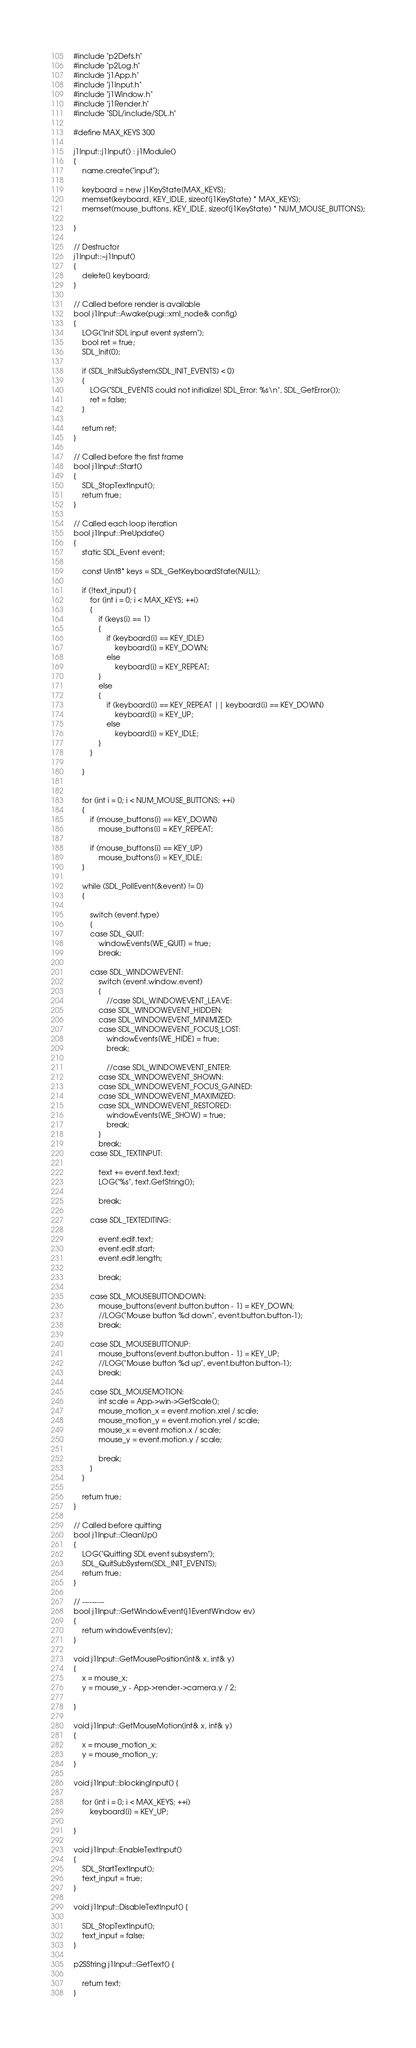Convert code to text. <code><loc_0><loc_0><loc_500><loc_500><_C++_>#include "p2Defs.h"
#include "p2Log.h"
#include "j1App.h"
#include "j1Input.h"
#include "j1Window.h"
#include "j1Render.h"
#include "SDL/include/SDL.h"

#define MAX_KEYS 300

j1Input::j1Input() : j1Module()
{
	name.create("input");

	keyboard = new j1KeyState[MAX_KEYS];
	memset(keyboard, KEY_IDLE, sizeof(j1KeyState) * MAX_KEYS);
	memset(mouse_buttons, KEY_IDLE, sizeof(j1KeyState) * NUM_MOUSE_BUTTONS);

}

// Destructor
j1Input::~j1Input()
{
	delete[] keyboard;
}

// Called before render is available
bool j1Input::Awake(pugi::xml_node& config)
{
	LOG("Init SDL input event system");
	bool ret = true;
	SDL_Init(0);

	if (SDL_InitSubSystem(SDL_INIT_EVENTS) < 0)
	{
		LOG("SDL_EVENTS could not initialize! SDL_Error: %s\n", SDL_GetError());
		ret = false;
	}

	return ret;
}

// Called before the first frame
bool j1Input::Start()
{
	SDL_StopTextInput();
	return true;
}

// Called each loop iteration
bool j1Input::PreUpdate()
{
	static SDL_Event event;

	const Uint8* keys = SDL_GetKeyboardState(NULL);

	if (!text_input) {
		for (int i = 0; i < MAX_KEYS; ++i)
		{
			if (keys[i] == 1)
			{
				if (keyboard[i] == KEY_IDLE)
					keyboard[i] = KEY_DOWN;
				else
					keyboard[i] = KEY_REPEAT;
			}
			else
			{
				if (keyboard[i] == KEY_REPEAT || keyboard[i] == KEY_DOWN)
					keyboard[i] = KEY_UP;
				else
					keyboard[i] = KEY_IDLE;
			}
		}

	}


	for (int i = 0; i < NUM_MOUSE_BUTTONS; ++i)
	{
		if (mouse_buttons[i] == KEY_DOWN)
			mouse_buttons[i] = KEY_REPEAT;

		if (mouse_buttons[i] == KEY_UP)
			mouse_buttons[i] = KEY_IDLE;
	}

	while (SDL_PollEvent(&event) != 0)
	{

		switch (event.type)
		{
		case SDL_QUIT:
			windowEvents[WE_QUIT] = true;
			break;

		case SDL_WINDOWEVENT:
			switch (event.window.event)
			{
				//case SDL_WINDOWEVENT_LEAVE:
			case SDL_WINDOWEVENT_HIDDEN:
			case SDL_WINDOWEVENT_MINIMIZED:
			case SDL_WINDOWEVENT_FOCUS_LOST:
				windowEvents[WE_HIDE] = true;
				break;

				//case SDL_WINDOWEVENT_ENTER:
			case SDL_WINDOWEVENT_SHOWN:
			case SDL_WINDOWEVENT_FOCUS_GAINED:
			case SDL_WINDOWEVENT_MAXIMIZED:
			case SDL_WINDOWEVENT_RESTORED:
				windowEvents[WE_SHOW] = true;
				break;
			}
			break;
		case SDL_TEXTINPUT:

			text += event.text.text;
			LOG("%s", text.GetString());

			break;

		case SDL_TEXTEDITING:

			event.edit.text;
			event.edit.start;
			event.edit.length;

			break;

		case SDL_MOUSEBUTTONDOWN:
			mouse_buttons[event.button.button - 1] = KEY_DOWN;
			//LOG("Mouse button %d down", event.button.button-1);
			break;

		case SDL_MOUSEBUTTONUP:
			mouse_buttons[event.button.button - 1] = KEY_UP;
			//LOG("Mouse button %d up", event.button.button-1);
			break;

		case SDL_MOUSEMOTION:
			int scale = App->win->GetScale();
			mouse_motion_x = event.motion.xrel / scale;
			mouse_motion_y = event.motion.yrel / scale;
			mouse_x = event.motion.x / scale;
			mouse_y = event.motion.y / scale;

			break;
		}
	}

	return true;
}

// Called before quitting
bool j1Input::CleanUp()
{
	LOG("Quitting SDL event subsystem");
	SDL_QuitSubSystem(SDL_INIT_EVENTS);
	return true;
}

// ---------
bool j1Input::GetWindowEvent(j1EventWindow ev)
{
	return windowEvents[ev];
}

void j1Input::GetMousePosition(int& x, int& y)
{
	x = mouse_x;
	y = mouse_y - App->render->camera.y / 2;

}

void j1Input::GetMouseMotion(int& x, int& y)
{
	x = mouse_motion_x;
	y = mouse_motion_y;
}

void j1Input::blockingInput() {

	for (int i = 0; i < MAX_KEYS; ++i)
		keyboard[i] = KEY_UP;

}

void j1Input::EnableTextInput()
{
	SDL_StartTextInput();
	text_input = true;
}

void j1Input::DisableTextInput() {

	SDL_StopTextInput();
	text_input = false;
}

p2SString j1Input::GetText() {

	return text;
}</code> 